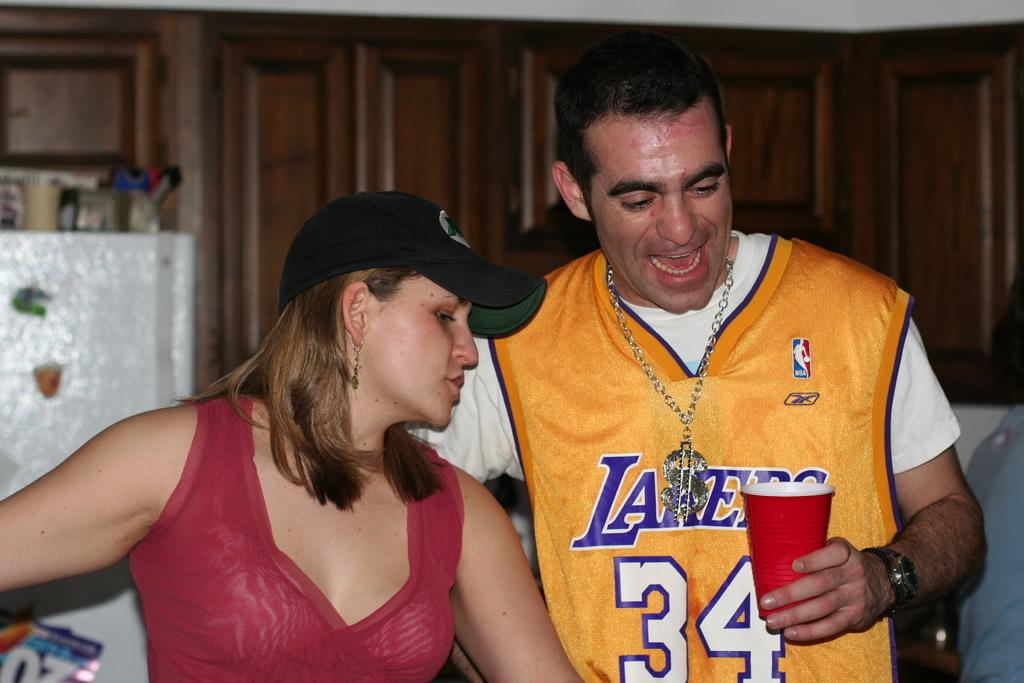<image>
Share a concise interpretation of the image provided. A woman and a man in a Lakers jersey look at a red solo cup. 